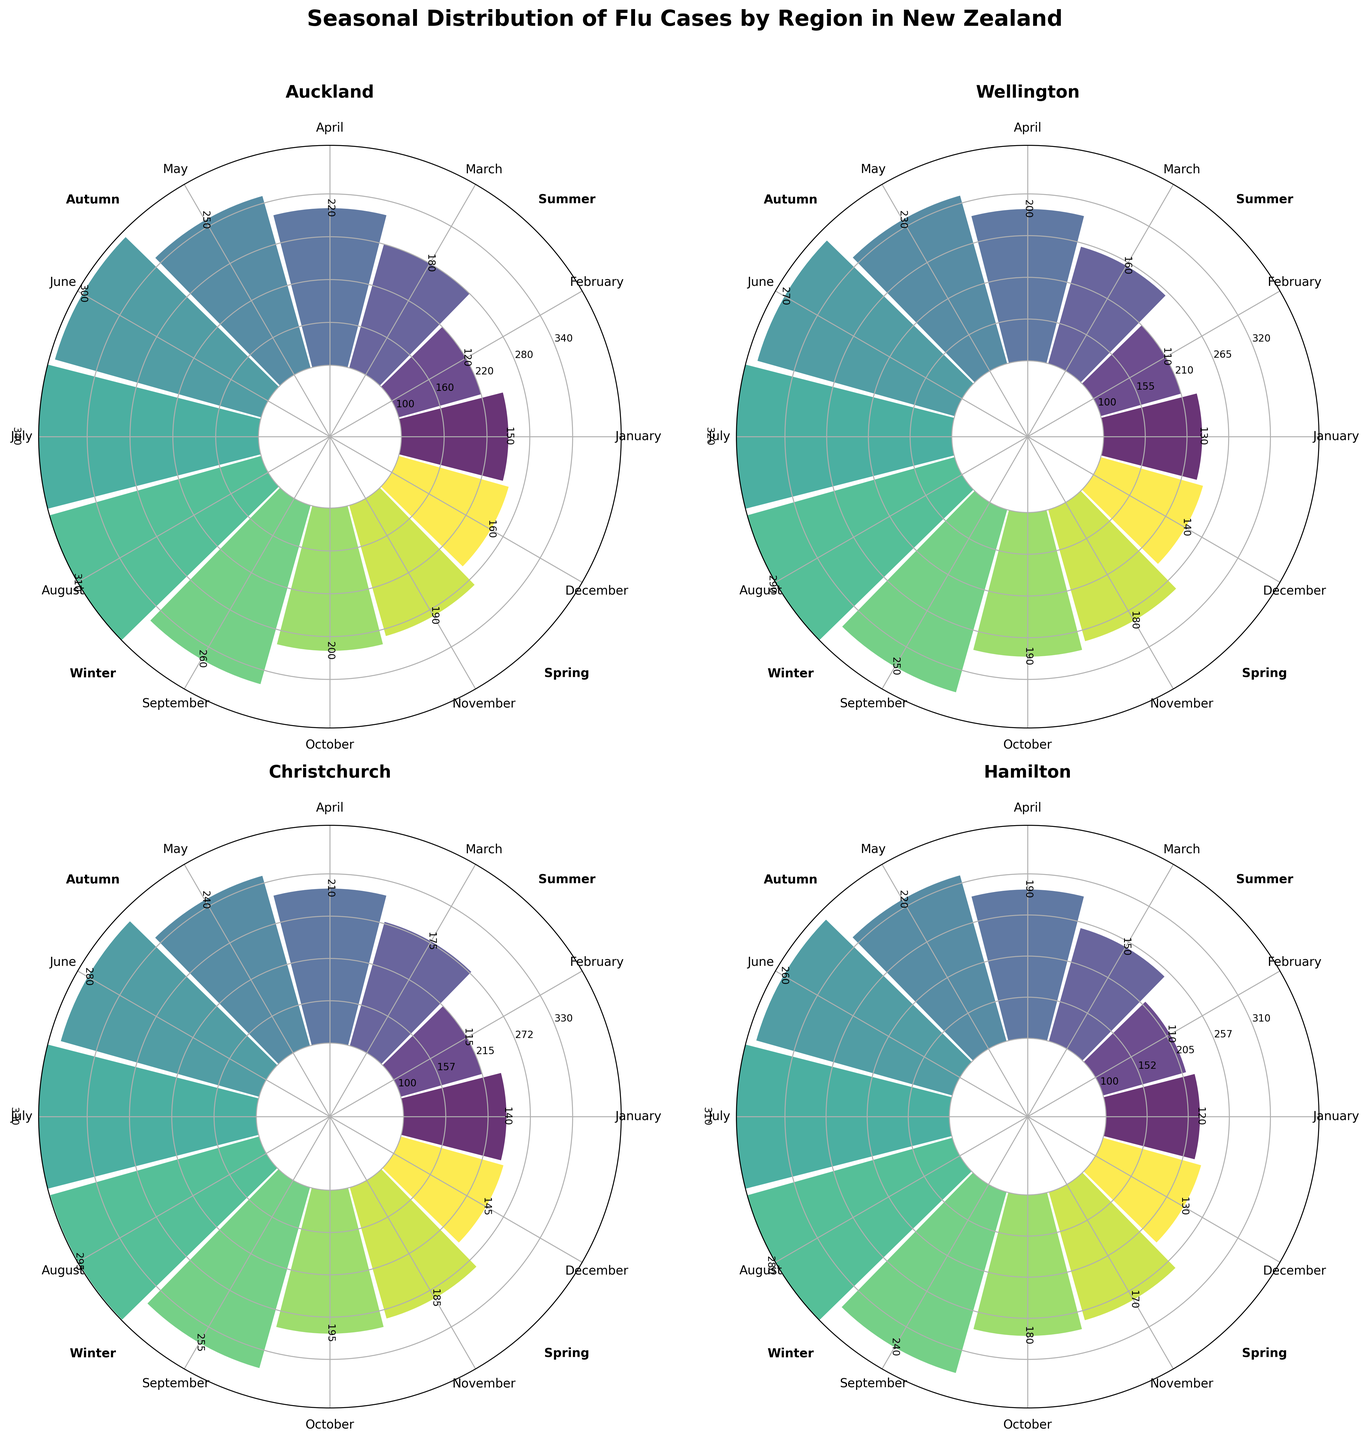What is the title of the figure? The title is displayed at the top center of the figure in bold and slightly larger font size than the rest. It reads "Seasonal Distribution of Flu Cases by Region in New Zealand".
Answer: Seasonal Distribution of Flu Cases by Region in New Zealand Which region has the highest number of flu cases in July? Look at the July section of each subplot and identify the one with the tallest bar. The highest bar in July appears in the Auckland subplot.
Answer: Auckland In which region are the flu cases lowest in February? Look at the February section of each subplot and identify the one with the shortest bar. The shortest bar in February is found in Hamilton.
Answer: Hamilton Compare the number of flu cases in June for Auckland and Wellington. Which region has more cases? Locate the June sections in both the Auckland and Wellington subplots. Auckland has 300 cases while Wellington has 270 cases. Auckland has more cases.
Answer: Auckland What is the average number of flu cases in August across all regions? Identify the August section in all subplots. Sum the cases: Auckland (310) + Wellington (290) + Christchurch (295) + Hamilton (280). The total is 1175. Divide by 4 to get the average, which is 1175 / 4 = 293.75.
Answer: 293.75 Which season sees the highest number of flu cases in Christchurch? For each season, sum the flu cases in the Christchurch subplot. Winter: (280 + 330 + 295) = 905. Autumn: (175 + 210 + 240) = 625. Spring: (255 + 195 + 185) = 635. Summer: (140 + 115 + 145) = 400. Winter has the highest total.
Answer: Winter During which month does Hamilton experience the highest flu cases? Identify the tallest bar in the Hamilton subplot. The highest bar appears in July with 310 cases.
Answer: July Is there any month where Wellington exhibits fewer than 120 flu cases? If so, which month? Examine the bars in the Wellington subplot to find any bar below 120 cases. The month of February has 110 cases, which is below 120.
Answer: February Compare the average number of flu cases in Summer and Autumn for Auckland. Which one has a higher average? Summarize cases for Summer: (150 + 120 + 160) = 430 and for Autumn: (180 + 220 + 250) = 650. Calculate the average for Summer: 430 / 3 ≈ 143.3 and for Autumn: 650 / 3 ≈ 216.7. Autumn has a higher average.
Answer: Autumn How many flu cases does Wellington have in Spring? Sum of flu cases for Spring months (September, October, November) in the Wellington subplot: 250 + 190 + 180 = 620.
Answer: 620 